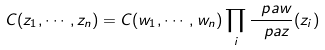Convert formula to latex. <formula><loc_0><loc_0><loc_500><loc_500>C ( z _ { 1 } , \cdots , z _ { n } ) = C ( w _ { 1 } , \cdots , w _ { n } ) \prod _ { i } \frac { \ p a w } { \ p a z } ( z _ { i } )</formula> 